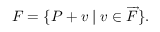Convert formula to latex. <formula><loc_0><loc_0><loc_500><loc_500>F = \{ P + v | v \in { \overrightarrow { F } } \} .</formula> 